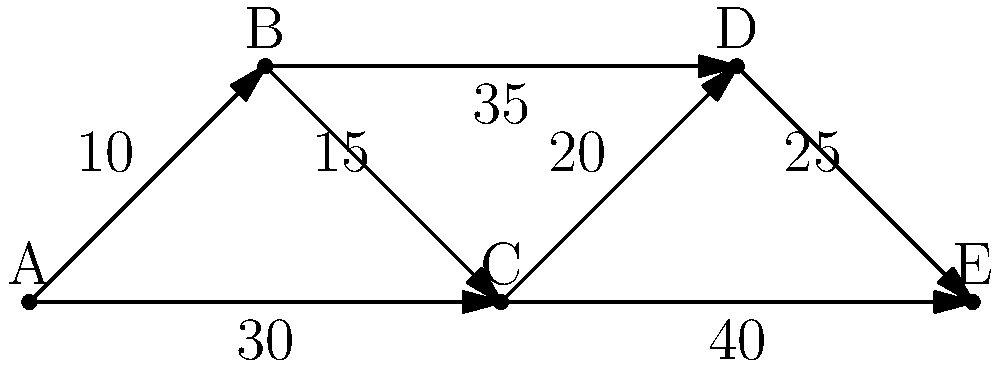Given the network diagram representing public transportation routes between five city districts (A, B, C, D, E), where the numbers on the edges represent the average CO2 emissions (in kg) per trip, what is the most environmentally friendly route from district A to district E, and what is the total CO2 emission for this route? To find the most environmentally friendly route from A to E, we need to calculate the total CO2 emissions for all possible paths and choose the one with the lowest total.

Possible routes:
1. A → B → C → D → E
2. A → B → C → E
3. A → C → D → E
4. A → C → E

Let's calculate the CO2 emissions for each route:

1. A → B → C → D → E:
   $10 + 15 + 20 + 25 = 70$ kg CO2

2. A → B → C → E:
   $10 + 15 + 40 = 65$ kg CO2

3. A → C → D → E:
   $30 + 20 + 25 = 75$ kg CO2

4. A → C → E:
   $30 + 40 = 70$ kg CO2

The route with the lowest CO2 emission is A → B → C → E, with a total of 65 kg CO2.
Answer: A → B → C → E, 65 kg CO2 